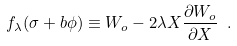<formula> <loc_0><loc_0><loc_500><loc_500>f _ { \lambda } ( \sigma + b \phi ) \equiv W _ { o } - 2 \lambda X \frac { \partial W _ { o } } { \partial X } \ .</formula> 